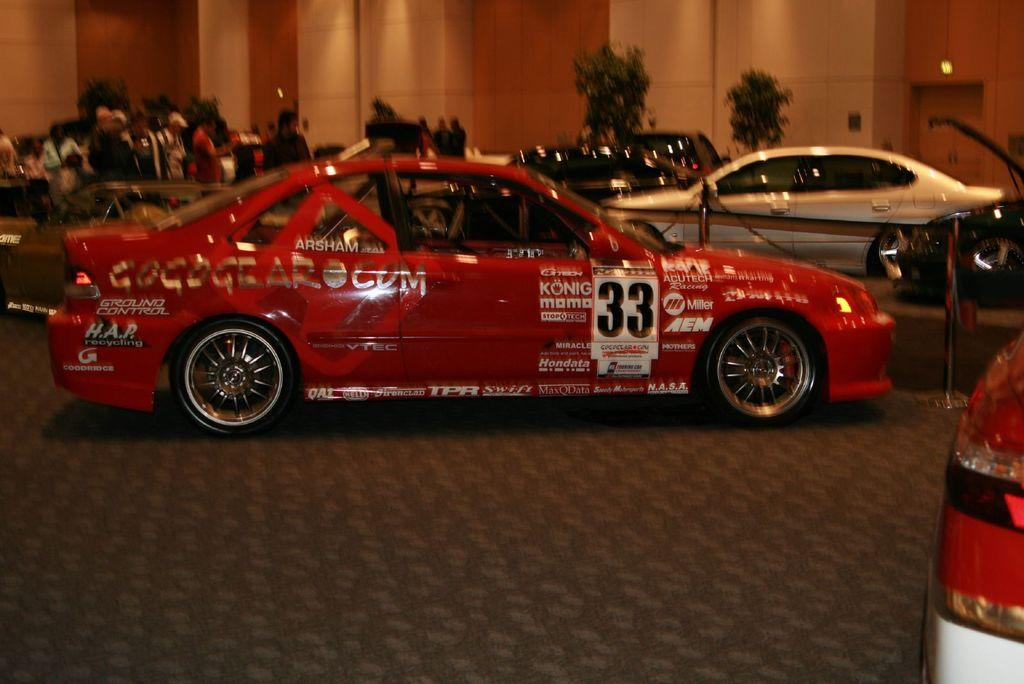What type of vehicles can be seen in the image? There are cars in the image. What other objects are present in the image besides cars? There are metal rods in the image. What can be seen in the background of the image? There is a group of people, trees, and lights in the background of the image. What type of coat is hanging on the hook in the image? There is no coat or hook present in the image. 